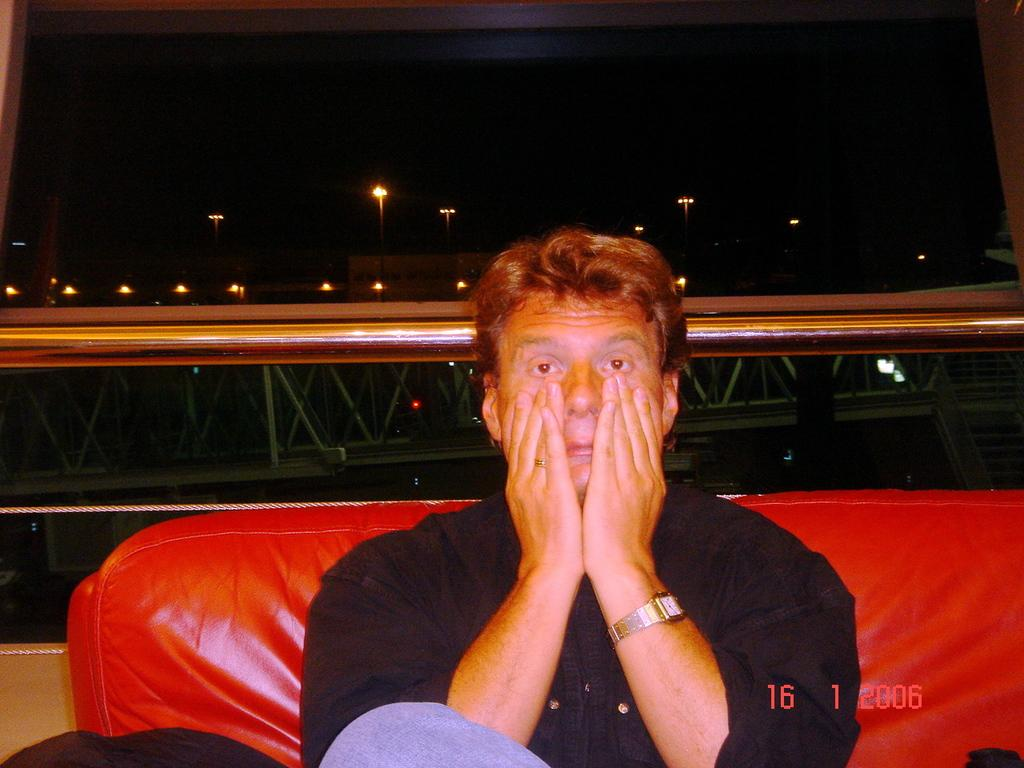What is the person in the image doing? There is a person sitting on the couch in the image. What can be seen in the background of the image? In the background, there are iron rods, lights, and the sky visible. Can you describe the lighting in the image? The lights in the background provide illumination in the image. Is there any indication of the image's origin or ownership? Yes, there is a watermark on the image. What type of bed is visible in the image? There is no bed present in the image; it features a person sitting on a couch. How does the sky in the image capture the viewer's attention? The sky is not the main focus of the image, as it is in the background and not the primary subject. 